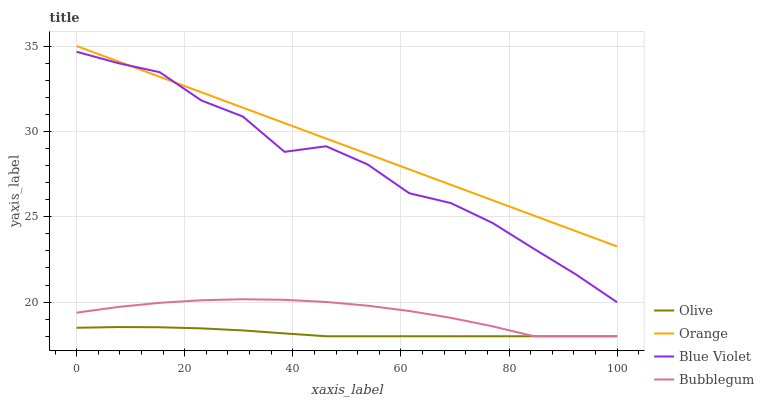Does Olive have the minimum area under the curve?
Answer yes or no. Yes. Does Orange have the maximum area under the curve?
Answer yes or no. Yes. Does Bubblegum have the minimum area under the curve?
Answer yes or no. No. Does Bubblegum have the maximum area under the curve?
Answer yes or no. No. Is Orange the smoothest?
Answer yes or no. Yes. Is Blue Violet the roughest?
Answer yes or no. Yes. Is Bubblegum the smoothest?
Answer yes or no. No. Is Bubblegum the roughest?
Answer yes or no. No. Does Olive have the lowest value?
Answer yes or no. Yes. Does Orange have the lowest value?
Answer yes or no. No. Does Orange have the highest value?
Answer yes or no. Yes. Does Bubblegum have the highest value?
Answer yes or no. No. Is Bubblegum less than Orange?
Answer yes or no. Yes. Is Blue Violet greater than Olive?
Answer yes or no. Yes. Does Blue Violet intersect Orange?
Answer yes or no. Yes. Is Blue Violet less than Orange?
Answer yes or no. No. Is Blue Violet greater than Orange?
Answer yes or no. No. Does Bubblegum intersect Orange?
Answer yes or no. No. 